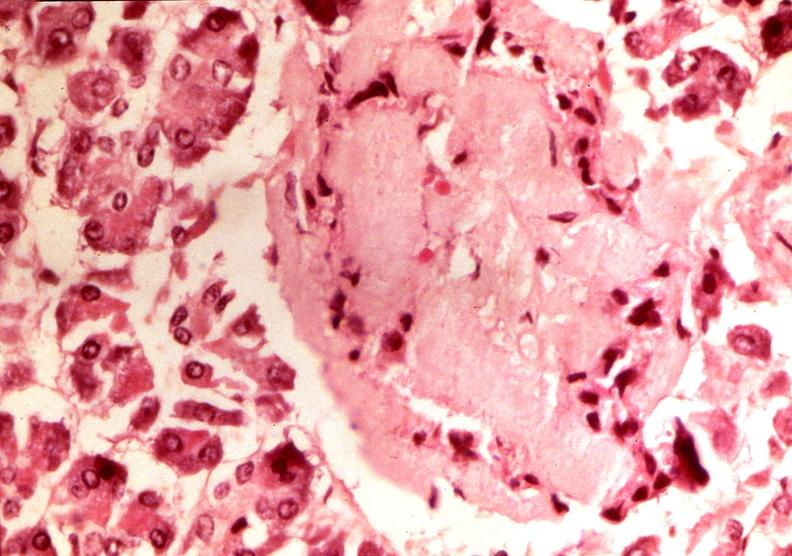where is this part in the figure?
Answer the question using a single word or phrase. Endocrine system 